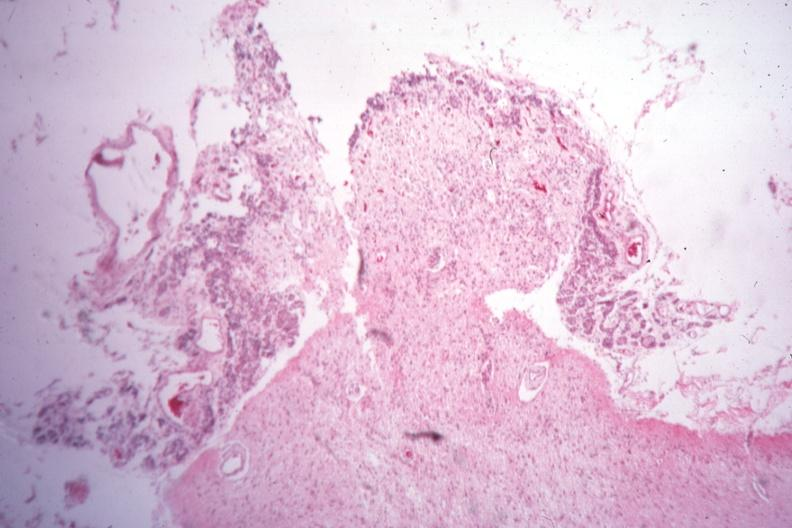what was empty case of type i diabetes with pituitectomy for retinal lesions 9 years?
Answer the question using a single word or phrase. Sella 